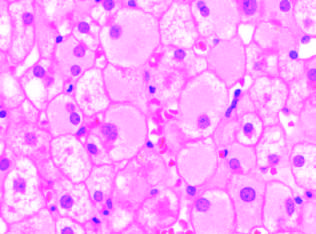do infected hepatocytes show diffuse granular cyto-plasm, reflecting accumulated hepatitis b surface antigen hbsag in chronic infections?
Answer the question using a single word or phrase. Yes 